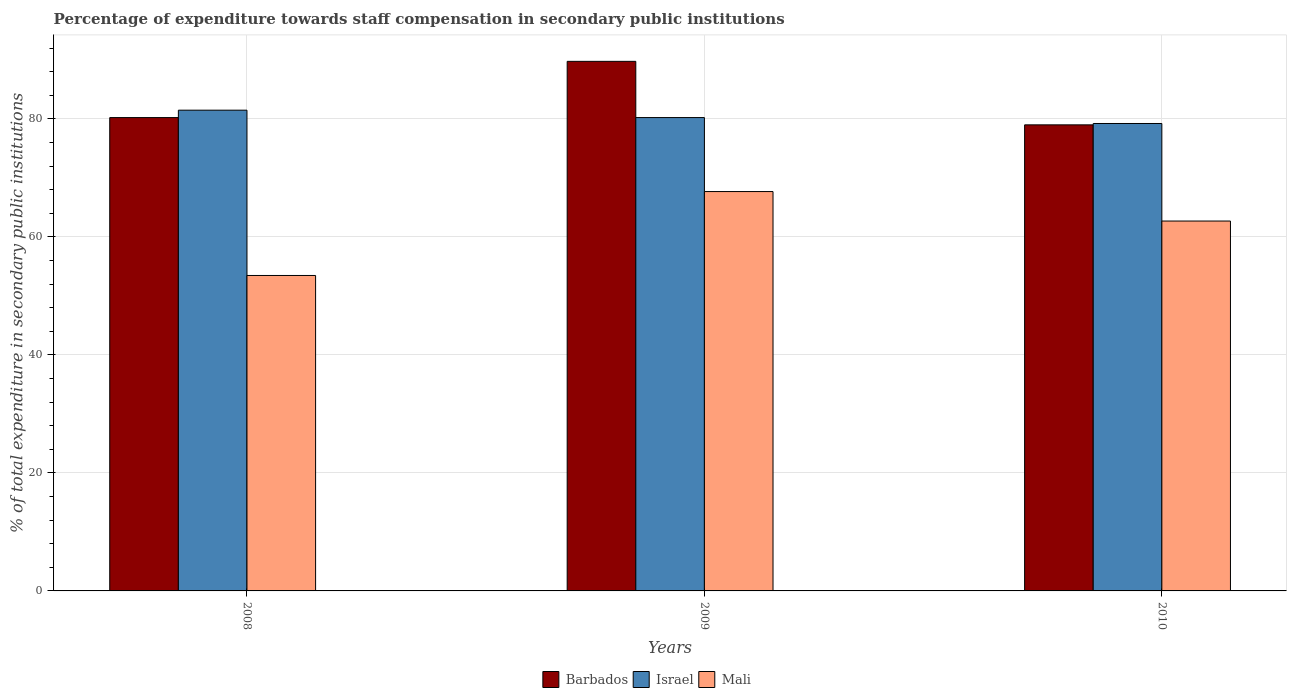How many different coloured bars are there?
Your response must be concise. 3. How many groups of bars are there?
Ensure brevity in your answer.  3. Are the number of bars per tick equal to the number of legend labels?
Make the answer very short. Yes. Are the number of bars on each tick of the X-axis equal?
Provide a succinct answer. Yes. How many bars are there on the 2nd tick from the left?
Your answer should be compact. 3. In how many cases, is the number of bars for a given year not equal to the number of legend labels?
Your answer should be very brief. 0. What is the percentage of expenditure towards staff compensation in Barbados in 2010?
Provide a succinct answer. 78.98. Across all years, what is the maximum percentage of expenditure towards staff compensation in Mali?
Ensure brevity in your answer.  67.68. Across all years, what is the minimum percentage of expenditure towards staff compensation in Barbados?
Your answer should be very brief. 78.98. In which year was the percentage of expenditure towards staff compensation in Israel maximum?
Your answer should be compact. 2008. In which year was the percentage of expenditure towards staff compensation in Barbados minimum?
Ensure brevity in your answer.  2010. What is the total percentage of expenditure towards staff compensation in Barbados in the graph?
Your response must be concise. 248.94. What is the difference between the percentage of expenditure towards staff compensation in Israel in 2009 and that in 2010?
Provide a succinct answer. 1. What is the difference between the percentage of expenditure towards staff compensation in Mali in 2010 and the percentage of expenditure towards staff compensation in Israel in 2009?
Keep it short and to the point. -17.53. What is the average percentage of expenditure towards staff compensation in Mali per year?
Keep it short and to the point. 61.27. In the year 2009, what is the difference between the percentage of expenditure towards staff compensation in Mali and percentage of expenditure towards staff compensation in Barbados?
Your response must be concise. -22.06. In how many years, is the percentage of expenditure towards staff compensation in Barbados greater than 64 %?
Your answer should be very brief. 3. What is the ratio of the percentage of expenditure towards staff compensation in Israel in 2008 to that in 2010?
Provide a short and direct response. 1.03. Is the percentage of expenditure towards staff compensation in Israel in 2008 less than that in 2010?
Your response must be concise. No. Is the difference between the percentage of expenditure towards staff compensation in Mali in 2008 and 2010 greater than the difference between the percentage of expenditure towards staff compensation in Barbados in 2008 and 2010?
Your response must be concise. No. What is the difference between the highest and the second highest percentage of expenditure towards staff compensation in Mali?
Keep it short and to the point. 5. What is the difference between the highest and the lowest percentage of expenditure towards staff compensation in Mali?
Offer a very short reply. 14.22. Is the sum of the percentage of expenditure towards staff compensation in Barbados in 2008 and 2010 greater than the maximum percentage of expenditure towards staff compensation in Israel across all years?
Provide a succinct answer. Yes. What does the 1st bar from the right in 2008 represents?
Make the answer very short. Mali. Is it the case that in every year, the sum of the percentage of expenditure towards staff compensation in Israel and percentage of expenditure towards staff compensation in Barbados is greater than the percentage of expenditure towards staff compensation in Mali?
Offer a terse response. Yes. How many bars are there?
Offer a very short reply. 9. Are all the bars in the graph horizontal?
Offer a terse response. No. Are the values on the major ticks of Y-axis written in scientific E-notation?
Provide a short and direct response. No. How many legend labels are there?
Your answer should be very brief. 3. How are the legend labels stacked?
Your response must be concise. Horizontal. What is the title of the graph?
Provide a succinct answer. Percentage of expenditure towards staff compensation in secondary public institutions. Does "South Asia" appear as one of the legend labels in the graph?
Your answer should be very brief. No. What is the label or title of the X-axis?
Give a very brief answer. Years. What is the label or title of the Y-axis?
Your response must be concise. % of total expenditure in secondary public institutions. What is the % of total expenditure in secondary public institutions of Barbados in 2008?
Your answer should be very brief. 80.22. What is the % of total expenditure in secondary public institutions in Israel in 2008?
Your answer should be compact. 81.47. What is the % of total expenditure in secondary public institutions in Mali in 2008?
Provide a short and direct response. 53.46. What is the % of total expenditure in secondary public institutions of Barbados in 2009?
Provide a short and direct response. 89.74. What is the % of total expenditure in secondary public institutions in Israel in 2009?
Provide a succinct answer. 80.22. What is the % of total expenditure in secondary public institutions of Mali in 2009?
Your answer should be compact. 67.68. What is the % of total expenditure in secondary public institutions of Barbados in 2010?
Your answer should be compact. 78.98. What is the % of total expenditure in secondary public institutions in Israel in 2010?
Give a very brief answer. 79.21. What is the % of total expenditure in secondary public institutions of Mali in 2010?
Offer a very short reply. 62.68. Across all years, what is the maximum % of total expenditure in secondary public institutions of Barbados?
Your answer should be compact. 89.74. Across all years, what is the maximum % of total expenditure in secondary public institutions of Israel?
Your answer should be very brief. 81.47. Across all years, what is the maximum % of total expenditure in secondary public institutions of Mali?
Provide a succinct answer. 67.68. Across all years, what is the minimum % of total expenditure in secondary public institutions of Barbados?
Offer a very short reply. 78.98. Across all years, what is the minimum % of total expenditure in secondary public institutions of Israel?
Offer a terse response. 79.21. Across all years, what is the minimum % of total expenditure in secondary public institutions of Mali?
Provide a succinct answer. 53.46. What is the total % of total expenditure in secondary public institutions of Barbados in the graph?
Your answer should be very brief. 248.94. What is the total % of total expenditure in secondary public institutions of Israel in the graph?
Provide a short and direct response. 240.9. What is the total % of total expenditure in secondary public institutions in Mali in the graph?
Make the answer very short. 183.82. What is the difference between the % of total expenditure in secondary public institutions of Barbados in 2008 and that in 2009?
Your answer should be very brief. -9.53. What is the difference between the % of total expenditure in secondary public institutions of Israel in 2008 and that in 2009?
Ensure brevity in your answer.  1.25. What is the difference between the % of total expenditure in secondary public institutions of Mali in 2008 and that in 2009?
Your answer should be very brief. -14.22. What is the difference between the % of total expenditure in secondary public institutions in Barbados in 2008 and that in 2010?
Make the answer very short. 1.23. What is the difference between the % of total expenditure in secondary public institutions in Israel in 2008 and that in 2010?
Your response must be concise. 2.26. What is the difference between the % of total expenditure in secondary public institutions in Mali in 2008 and that in 2010?
Keep it short and to the point. -9.23. What is the difference between the % of total expenditure in secondary public institutions of Barbados in 2009 and that in 2010?
Your answer should be compact. 10.76. What is the difference between the % of total expenditure in secondary public institutions in Mali in 2009 and that in 2010?
Give a very brief answer. 5. What is the difference between the % of total expenditure in secondary public institutions of Barbados in 2008 and the % of total expenditure in secondary public institutions of Israel in 2009?
Offer a very short reply. -0. What is the difference between the % of total expenditure in secondary public institutions of Barbados in 2008 and the % of total expenditure in secondary public institutions of Mali in 2009?
Make the answer very short. 12.54. What is the difference between the % of total expenditure in secondary public institutions in Israel in 2008 and the % of total expenditure in secondary public institutions in Mali in 2009?
Your answer should be very brief. 13.79. What is the difference between the % of total expenditure in secondary public institutions of Barbados in 2008 and the % of total expenditure in secondary public institutions of Israel in 2010?
Offer a terse response. 1. What is the difference between the % of total expenditure in secondary public institutions in Barbados in 2008 and the % of total expenditure in secondary public institutions in Mali in 2010?
Give a very brief answer. 17.53. What is the difference between the % of total expenditure in secondary public institutions in Israel in 2008 and the % of total expenditure in secondary public institutions in Mali in 2010?
Your answer should be very brief. 18.79. What is the difference between the % of total expenditure in secondary public institutions in Barbados in 2009 and the % of total expenditure in secondary public institutions in Israel in 2010?
Give a very brief answer. 10.53. What is the difference between the % of total expenditure in secondary public institutions of Barbados in 2009 and the % of total expenditure in secondary public institutions of Mali in 2010?
Your answer should be compact. 27.06. What is the difference between the % of total expenditure in secondary public institutions of Israel in 2009 and the % of total expenditure in secondary public institutions of Mali in 2010?
Your answer should be compact. 17.53. What is the average % of total expenditure in secondary public institutions in Barbados per year?
Offer a very short reply. 82.98. What is the average % of total expenditure in secondary public institutions of Israel per year?
Provide a short and direct response. 80.3. What is the average % of total expenditure in secondary public institutions in Mali per year?
Offer a very short reply. 61.27. In the year 2008, what is the difference between the % of total expenditure in secondary public institutions of Barbados and % of total expenditure in secondary public institutions of Israel?
Your answer should be compact. -1.25. In the year 2008, what is the difference between the % of total expenditure in secondary public institutions of Barbados and % of total expenditure in secondary public institutions of Mali?
Provide a succinct answer. 26.76. In the year 2008, what is the difference between the % of total expenditure in secondary public institutions in Israel and % of total expenditure in secondary public institutions in Mali?
Offer a terse response. 28.01. In the year 2009, what is the difference between the % of total expenditure in secondary public institutions of Barbados and % of total expenditure in secondary public institutions of Israel?
Provide a short and direct response. 9.53. In the year 2009, what is the difference between the % of total expenditure in secondary public institutions of Barbados and % of total expenditure in secondary public institutions of Mali?
Your answer should be compact. 22.06. In the year 2009, what is the difference between the % of total expenditure in secondary public institutions in Israel and % of total expenditure in secondary public institutions in Mali?
Make the answer very short. 12.54. In the year 2010, what is the difference between the % of total expenditure in secondary public institutions in Barbados and % of total expenditure in secondary public institutions in Israel?
Your answer should be compact. -0.23. In the year 2010, what is the difference between the % of total expenditure in secondary public institutions in Barbados and % of total expenditure in secondary public institutions in Mali?
Offer a very short reply. 16.3. In the year 2010, what is the difference between the % of total expenditure in secondary public institutions of Israel and % of total expenditure in secondary public institutions of Mali?
Provide a succinct answer. 16.53. What is the ratio of the % of total expenditure in secondary public institutions of Barbados in 2008 to that in 2009?
Offer a terse response. 0.89. What is the ratio of the % of total expenditure in secondary public institutions in Israel in 2008 to that in 2009?
Provide a short and direct response. 1.02. What is the ratio of the % of total expenditure in secondary public institutions of Mali in 2008 to that in 2009?
Provide a short and direct response. 0.79. What is the ratio of the % of total expenditure in secondary public institutions of Barbados in 2008 to that in 2010?
Your response must be concise. 1.02. What is the ratio of the % of total expenditure in secondary public institutions of Israel in 2008 to that in 2010?
Make the answer very short. 1.03. What is the ratio of the % of total expenditure in secondary public institutions in Mali in 2008 to that in 2010?
Provide a succinct answer. 0.85. What is the ratio of the % of total expenditure in secondary public institutions in Barbados in 2009 to that in 2010?
Your answer should be compact. 1.14. What is the ratio of the % of total expenditure in secondary public institutions of Israel in 2009 to that in 2010?
Your response must be concise. 1.01. What is the ratio of the % of total expenditure in secondary public institutions of Mali in 2009 to that in 2010?
Provide a succinct answer. 1.08. What is the difference between the highest and the second highest % of total expenditure in secondary public institutions in Barbados?
Provide a short and direct response. 9.53. What is the difference between the highest and the second highest % of total expenditure in secondary public institutions in Israel?
Ensure brevity in your answer.  1.25. What is the difference between the highest and the second highest % of total expenditure in secondary public institutions of Mali?
Make the answer very short. 5. What is the difference between the highest and the lowest % of total expenditure in secondary public institutions of Barbados?
Make the answer very short. 10.76. What is the difference between the highest and the lowest % of total expenditure in secondary public institutions of Israel?
Provide a succinct answer. 2.26. What is the difference between the highest and the lowest % of total expenditure in secondary public institutions of Mali?
Your answer should be compact. 14.22. 